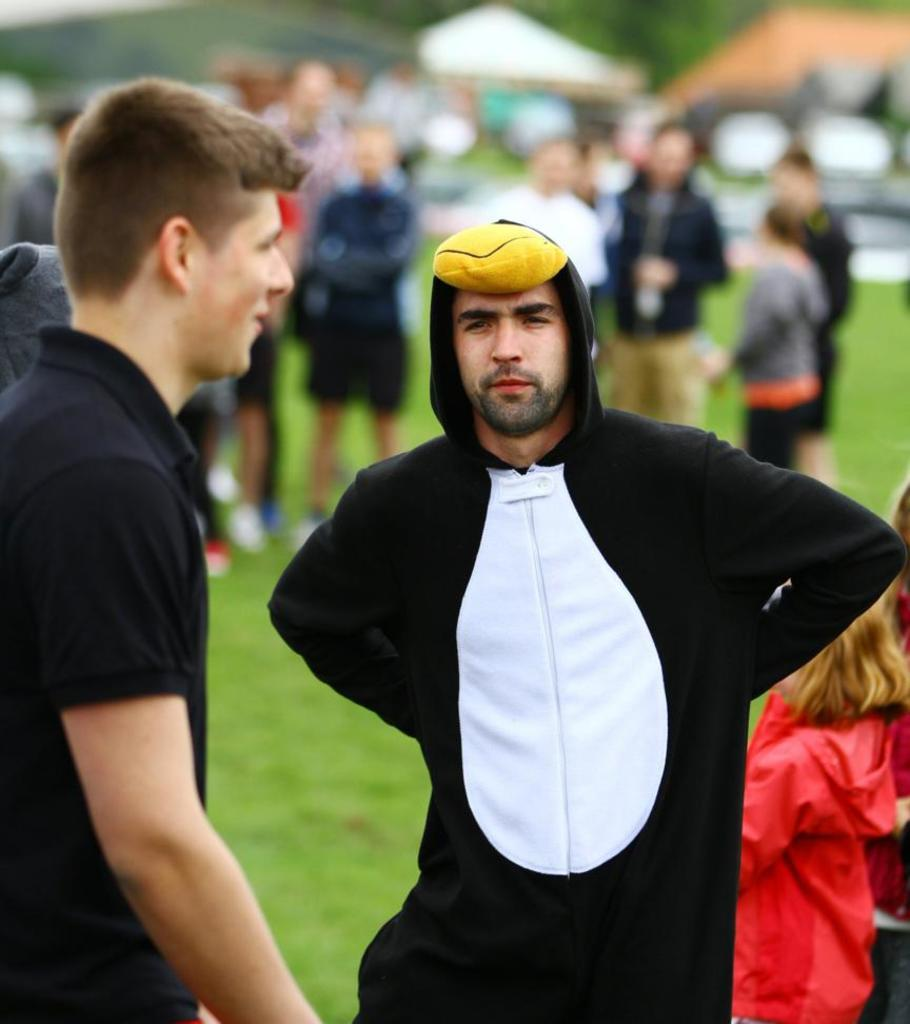What are the people in the image doing? The people in the image are standing on the ground. Can you describe the appearance of the man in the front? The man in the front is wearing a costume. What can be observed about the background of the image? The background of the image is blurred. What type of polish is the man applying to the roof in the image? There is no man applying polish to a roof in the image; the man in the front is wearing a costume, and there is no mention of a roof or polish. 